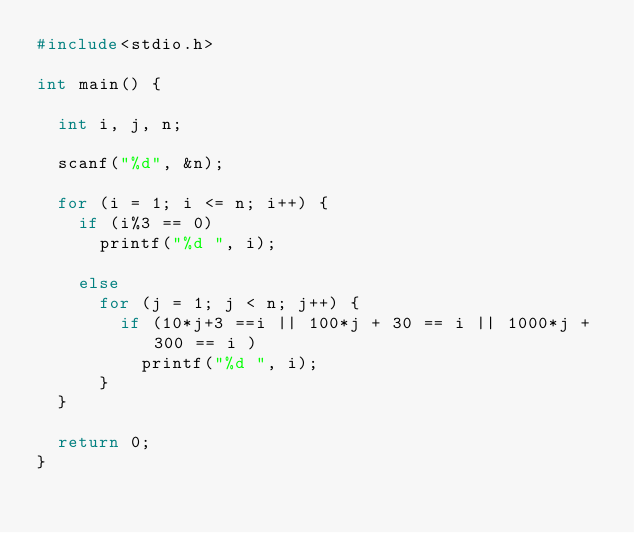Convert code to text. <code><loc_0><loc_0><loc_500><loc_500><_C_>#include<stdio.h>

int main() {

  int i, j, n;

  scanf("%d", &n);

  for (i = 1; i <= n; i++) {
    if (i%3 == 0)
      printf("%d ", i);

    else
      for (j = 1; j < n; j++) {
        if (10*j+3 ==i || 100*j + 30 == i || 1000*j + 300 == i )
          printf("%d ", i);
      }
  }

  return 0;
}</code> 